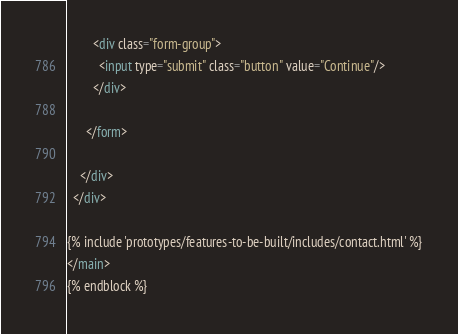Convert code to text. <code><loc_0><loc_0><loc_500><loc_500><_HTML_>





        <div class="form-group">
          <input type="submit" class="button" value="Continue"/>
        </div>

      </form>

    </div>
  </div>

{% include 'prototypes/features-to-be-built/includes/contact.html' %}
</main>
{% endblock %}
</code> 